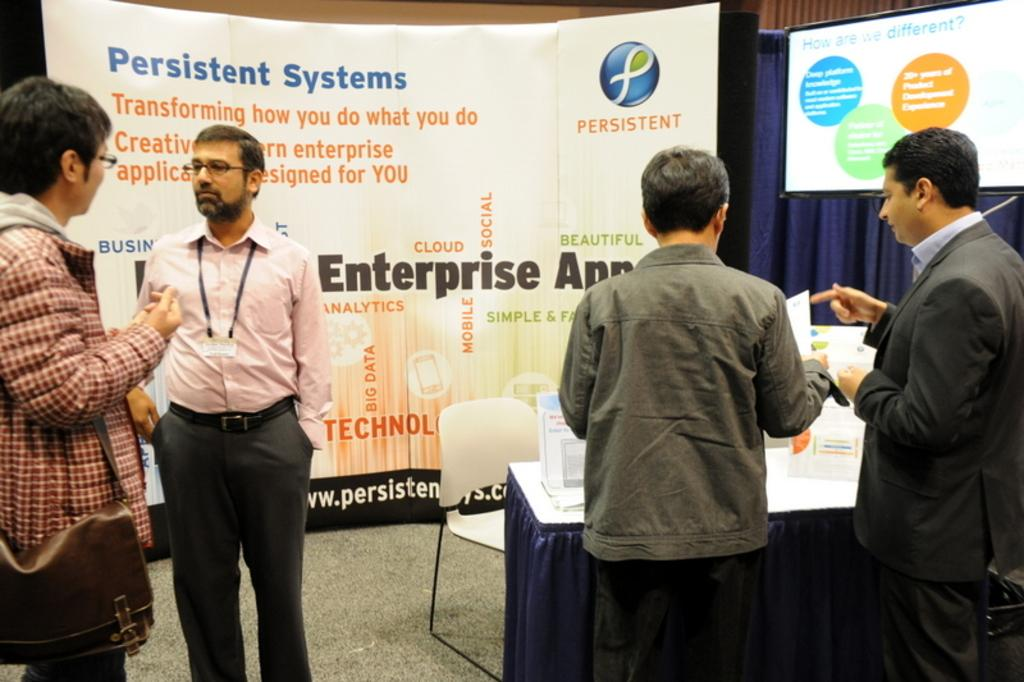How many people are in the image? There are four men in the image. What are the men doing in the image? The men are standing. What objects can be seen in the background of the image? There is a table, a chair, a banner, and a TV screen in the background of the image. Can you see a ladybug crawling on the banner in the image? There is no ladybug present in the image. What type of meeting is taking place in the image? The image does not depict a meeting; it shows four men standing with objects in the background. 